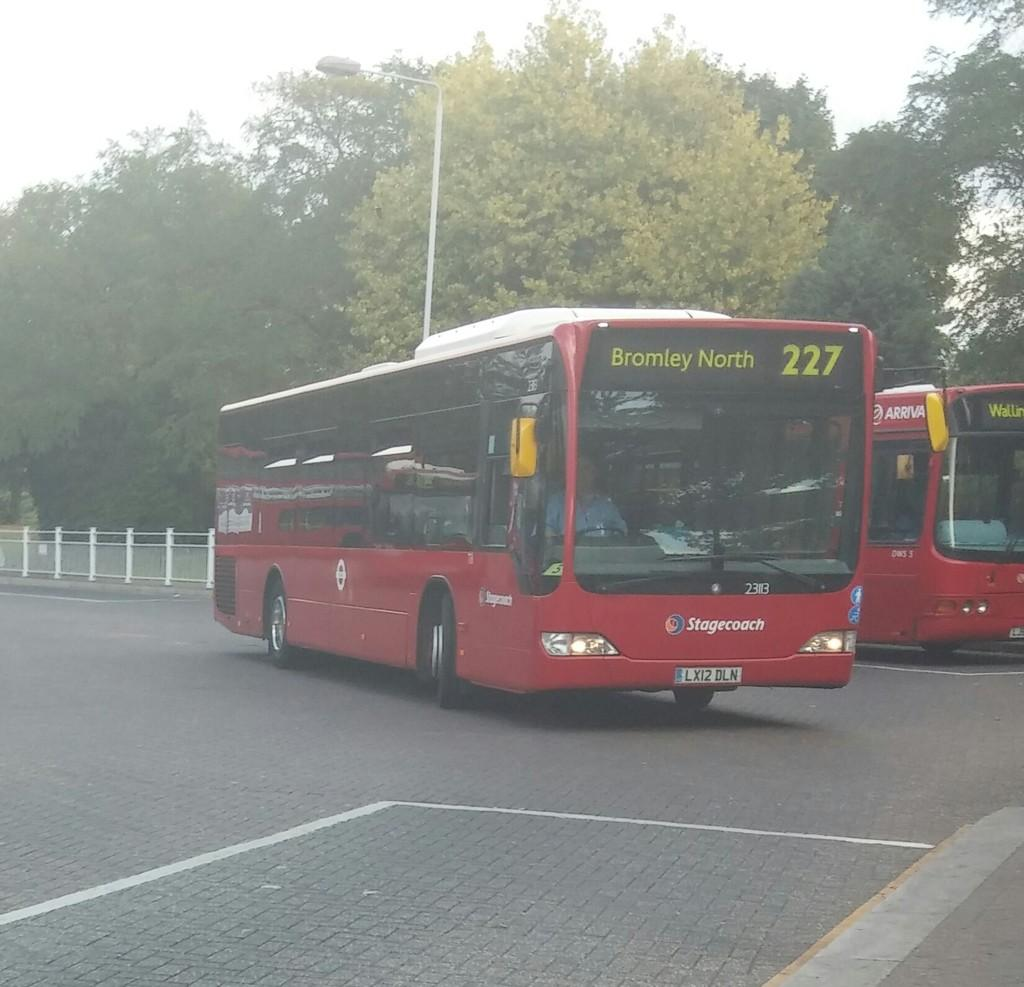What can be seen on the road in the image? There are vehicles on the road in the image. What is the tall, vertical object in the image? There is a pole in the image. What is attached to the pole in the image? There is a light attached to the pole in the image. What type of vegetation is present in the image? There are trees in the image. What is visible in the background of the image? The sky is visible in the background of the image. How many baby chickens are sitting on the pole in the image? There are no baby chickens present in the image; it features vehicles on the road, a pole with a light, trees, and a visible sky. 